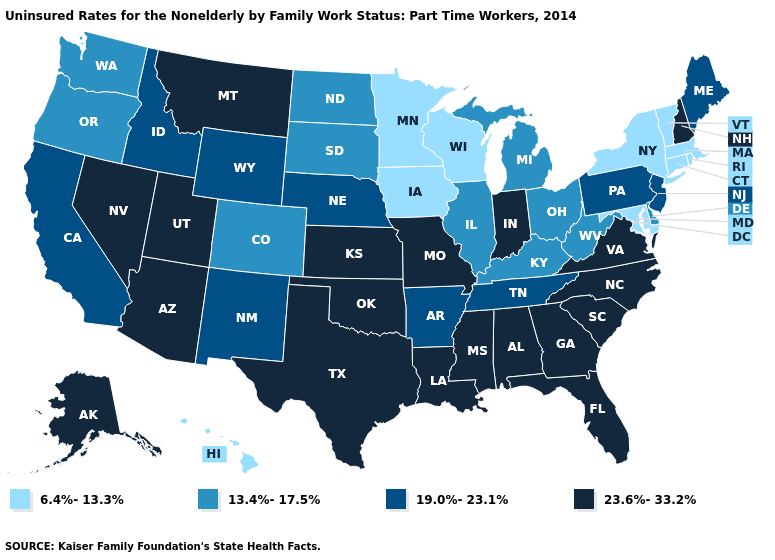Among the states that border Michigan , which have the lowest value?
Quick response, please. Wisconsin. What is the value of North Carolina?
Write a very short answer. 23.6%-33.2%. Does Tennessee have the highest value in the South?
Concise answer only. No. Does Nevada have the same value as Maryland?
Give a very brief answer. No. Name the states that have a value in the range 23.6%-33.2%?
Be succinct. Alabama, Alaska, Arizona, Florida, Georgia, Indiana, Kansas, Louisiana, Mississippi, Missouri, Montana, Nevada, New Hampshire, North Carolina, Oklahoma, South Carolina, Texas, Utah, Virginia. Does Virginia have the highest value in the South?
Keep it brief. Yes. What is the value of California?
Quick response, please. 19.0%-23.1%. What is the value of Louisiana?
Write a very short answer. 23.6%-33.2%. What is the value of Idaho?
Write a very short answer. 19.0%-23.1%. What is the value of West Virginia?
Short answer required. 13.4%-17.5%. Among the states that border Alabama , does Tennessee have the lowest value?
Give a very brief answer. Yes. Does Connecticut have the lowest value in the USA?
Answer briefly. Yes. Does Idaho have the lowest value in the West?
Be succinct. No. Which states have the highest value in the USA?
Give a very brief answer. Alabama, Alaska, Arizona, Florida, Georgia, Indiana, Kansas, Louisiana, Mississippi, Missouri, Montana, Nevada, New Hampshire, North Carolina, Oklahoma, South Carolina, Texas, Utah, Virginia. Does the map have missing data?
Write a very short answer. No. 